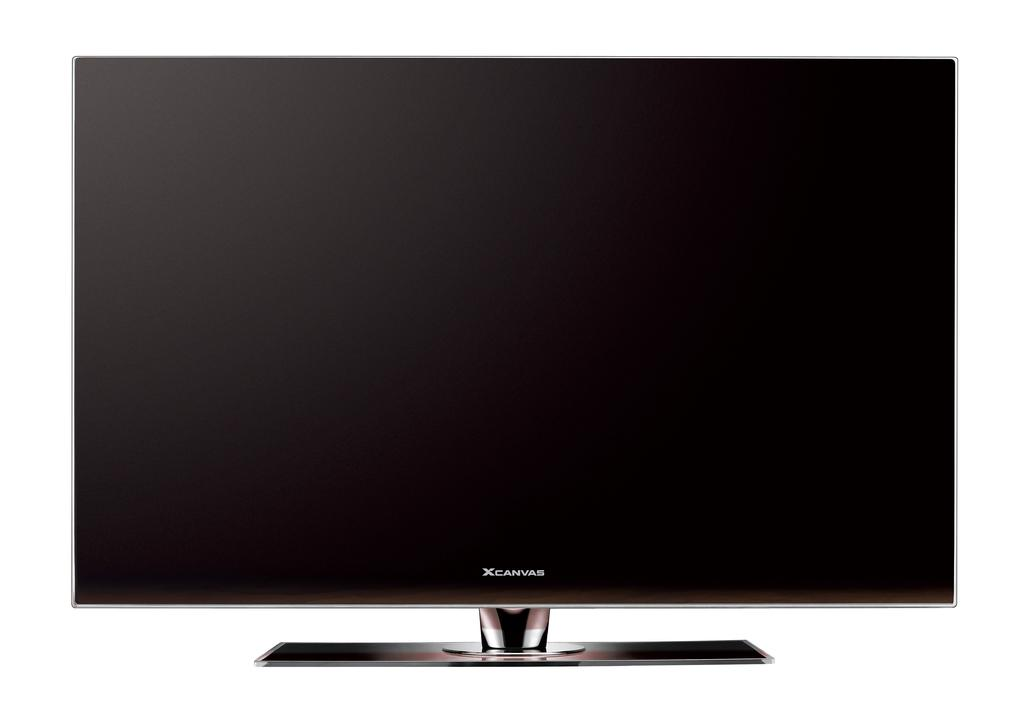<image>
Relay a brief, clear account of the picture shown. A flat screen TV that says XCanvas is on a white background. 